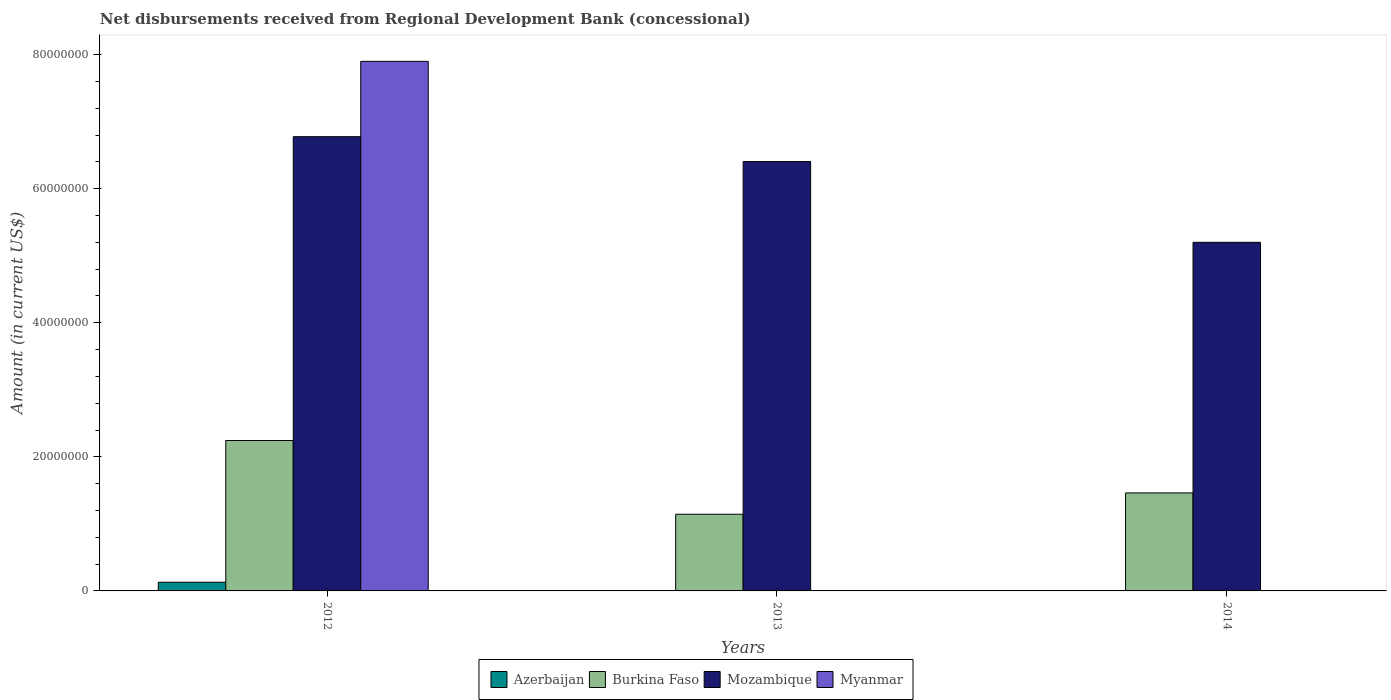How many groups of bars are there?
Provide a short and direct response. 3. Are the number of bars per tick equal to the number of legend labels?
Offer a terse response. No. Are the number of bars on each tick of the X-axis equal?
Ensure brevity in your answer.  No. What is the label of the 2nd group of bars from the left?
Give a very brief answer. 2013. In how many cases, is the number of bars for a given year not equal to the number of legend labels?
Your answer should be very brief. 2. What is the amount of disbursements received from Regional Development Bank in Mozambique in 2013?
Your answer should be very brief. 6.40e+07. Across all years, what is the maximum amount of disbursements received from Regional Development Bank in Myanmar?
Provide a short and direct response. 7.90e+07. Across all years, what is the minimum amount of disbursements received from Regional Development Bank in Burkina Faso?
Provide a short and direct response. 1.14e+07. In which year was the amount of disbursements received from Regional Development Bank in Burkina Faso maximum?
Your answer should be very brief. 2012. What is the total amount of disbursements received from Regional Development Bank in Myanmar in the graph?
Offer a terse response. 7.90e+07. What is the difference between the amount of disbursements received from Regional Development Bank in Burkina Faso in 2012 and that in 2013?
Offer a very short reply. 1.10e+07. What is the difference between the amount of disbursements received from Regional Development Bank in Mozambique in 2014 and the amount of disbursements received from Regional Development Bank in Myanmar in 2012?
Offer a terse response. -2.70e+07. What is the average amount of disbursements received from Regional Development Bank in Mozambique per year?
Provide a succinct answer. 6.13e+07. In the year 2012, what is the difference between the amount of disbursements received from Regional Development Bank in Azerbaijan and amount of disbursements received from Regional Development Bank in Mozambique?
Your answer should be very brief. -6.65e+07. What is the ratio of the amount of disbursements received from Regional Development Bank in Burkina Faso in 2012 to that in 2014?
Offer a terse response. 1.53. What is the difference between the highest and the second highest amount of disbursements received from Regional Development Bank in Mozambique?
Give a very brief answer. 3.71e+06. What is the difference between the highest and the lowest amount of disbursements received from Regional Development Bank in Burkina Faso?
Your answer should be compact. 1.10e+07. Is the sum of the amount of disbursements received from Regional Development Bank in Burkina Faso in 2013 and 2014 greater than the maximum amount of disbursements received from Regional Development Bank in Myanmar across all years?
Offer a very short reply. No. Is it the case that in every year, the sum of the amount of disbursements received from Regional Development Bank in Myanmar and amount of disbursements received from Regional Development Bank in Mozambique is greater than the amount of disbursements received from Regional Development Bank in Azerbaijan?
Offer a very short reply. Yes. How many years are there in the graph?
Make the answer very short. 3. What is the difference between two consecutive major ticks on the Y-axis?
Your answer should be very brief. 2.00e+07. Does the graph contain any zero values?
Offer a terse response. Yes. Where does the legend appear in the graph?
Make the answer very short. Bottom center. What is the title of the graph?
Provide a short and direct response. Net disbursements received from Regional Development Bank (concessional). What is the label or title of the Y-axis?
Make the answer very short. Amount (in current US$). What is the Amount (in current US$) of Azerbaijan in 2012?
Your response must be concise. 1.30e+06. What is the Amount (in current US$) in Burkina Faso in 2012?
Give a very brief answer. 2.24e+07. What is the Amount (in current US$) of Mozambique in 2012?
Your answer should be compact. 6.78e+07. What is the Amount (in current US$) in Myanmar in 2012?
Make the answer very short. 7.90e+07. What is the Amount (in current US$) in Azerbaijan in 2013?
Your answer should be compact. 0. What is the Amount (in current US$) of Burkina Faso in 2013?
Provide a short and direct response. 1.14e+07. What is the Amount (in current US$) in Mozambique in 2013?
Your response must be concise. 6.40e+07. What is the Amount (in current US$) of Myanmar in 2013?
Your answer should be compact. 0. What is the Amount (in current US$) in Burkina Faso in 2014?
Your answer should be very brief. 1.46e+07. What is the Amount (in current US$) in Mozambique in 2014?
Offer a very short reply. 5.20e+07. What is the Amount (in current US$) in Myanmar in 2014?
Your response must be concise. 0. Across all years, what is the maximum Amount (in current US$) in Azerbaijan?
Keep it short and to the point. 1.30e+06. Across all years, what is the maximum Amount (in current US$) in Burkina Faso?
Give a very brief answer. 2.24e+07. Across all years, what is the maximum Amount (in current US$) in Mozambique?
Your answer should be very brief. 6.78e+07. Across all years, what is the maximum Amount (in current US$) in Myanmar?
Ensure brevity in your answer.  7.90e+07. Across all years, what is the minimum Amount (in current US$) of Burkina Faso?
Keep it short and to the point. 1.14e+07. Across all years, what is the minimum Amount (in current US$) in Mozambique?
Provide a succinct answer. 5.20e+07. Across all years, what is the minimum Amount (in current US$) in Myanmar?
Your response must be concise. 0. What is the total Amount (in current US$) in Azerbaijan in the graph?
Your answer should be very brief. 1.30e+06. What is the total Amount (in current US$) in Burkina Faso in the graph?
Give a very brief answer. 4.85e+07. What is the total Amount (in current US$) in Mozambique in the graph?
Make the answer very short. 1.84e+08. What is the total Amount (in current US$) in Myanmar in the graph?
Ensure brevity in your answer.  7.90e+07. What is the difference between the Amount (in current US$) of Burkina Faso in 2012 and that in 2013?
Offer a very short reply. 1.10e+07. What is the difference between the Amount (in current US$) of Mozambique in 2012 and that in 2013?
Offer a terse response. 3.71e+06. What is the difference between the Amount (in current US$) in Burkina Faso in 2012 and that in 2014?
Your answer should be compact. 7.82e+06. What is the difference between the Amount (in current US$) in Mozambique in 2012 and that in 2014?
Provide a short and direct response. 1.58e+07. What is the difference between the Amount (in current US$) in Burkina Faso in 2013 and that in 2014?
Keep it short and to the point. -3.18e+06. What is the difference between the Amount (in current US$) of Mozambique in 2013 and that in 2014?
Ensure brevity in your answer.  1.20e+07. What is the difference between the Amount (in current US$) of Azerbaijan in 2012 and the Amount (in current US$) of Burkina Faso in 2013?
Provide a succinct answer. -1.01e+07. What is the difference between the Amount (in current US$) in Azerbaijan in 2012 and the Amount (in current US$) in Mozambique in 2013?
Ensure brevity in your answer.  -6.27e+07. What is the difference between the Amount (in current US$) of Burkina Faso in 2012 and the Amount (in current US$) of Mozambique in 2013?
Keep it short and to the point. -4.16e+07. What is the difference between the Amount (in current US$) of Azerbaijan in 2012 and the Amount (in current US$) of Burkina Faso in 2014?
Your answer should be very brief. -1.33e+07. What is the difference between the Amount (in current US$) in Azerbaijan in 2012 and the Amount (in current US$) in Mozambique in 2014?
Provide a succinct answer. -5.07e+07. What is the difference between the Amount (in current US$) in Burkina Faso in 2012 and the Amount (in current US$) in Mozambique in 2014?
Ensure brevity in your answer.  -2.96e+07. What is the difference between the Amount (in current US$) in Burkina Faso in 2013 and the Amount (in current US$) in Mozambique in 2014?
Provide a succinct answer. -4.06e+07. What is the average Amount (in current US$) of Azerbaijan per year?
Your answer should be very brief. 4.32e+05. What is the average Amount (in current US$) of Burkina Faso per year?
Ensure brevity in your answer.  1.62e+07. What is the average Amount (in current US$) in Mozambique per year?
Ensure brevity in your answer.  6.13e+07. What is the average Amount (in current US$) in Myanmar per year?
Give a very brief answer. 2.63e+07. In the year 2012, what is the difference between the Amount (in current US$) of Azerbaijan and Amount (in current US$) of Burkina Faso?
Offer a terse response. -2.11e+07. In the year 2012, what is the difference between the Amount (in current US$) in Azerbaijan and Amount (in current US$) in Mozambique?
Offer a very short reply. -6.65e+07. In the year 2012, what is the difference between the Amount (in current US$) of Azerbaijan and Amount (in current US$) of Myanmar?
Provide a succinct answer. -7.77e+07. In the year 2012, what is the difference between the Amount (in current US$) of Burkina Faso and Amount (in current US$) of Mozambique?
Provide a short and direct response. -4.53e+07. In the year 2012, what is the difference between the Amount (in current US$) of Burkina Faso and Amount (in current US$) of Myanmar?
Make the answer very short. -5.66e+07. In the year 2012, what is the difference between the Amount (in current US$) in Mozambique and Amount (in current US$) in Myanmar?
Offer a very short reply. -1.12e+07. In the year 2013, what is the difference between the Amount (in current US$) of Burkina Faso and Amount (in current US$) of Mozambique?
Your answer should be compact. -5.26e+07. In the year 2014, what is the difference between the Amount (in current US$) of Burkina Faso and Amount (in current US$) of Mozambique?
Ensure brevity in your answer.  -3.74e+07. What is the ratio of the Amount (in current US$) in Burkina Faso in 2012 to that in 2013?
Give a very brief answer. 1.96. What is the ratio of the Amount (in current US$) of Mozambique in 2012 to that in 2013?
Make the answer very short. 1.06. What is the ratio of the Amount (in current US$) in Burkina Faso in 2012 to that in 2014?
Offer a terse response. 1.53. What is the ratio of the Amount (in current US$) of Mozambique in 2012 to that in 2014?
Your answer should be very brief. 1.3. What is the ratio of the Amount (in current US$) in Burkina Faso in 2013 to that in 2014?
Make the answer very short. 0.78. What is the ratio of the Amount (in current US$) in Mozambique in 2013 to that in 2014?
Your response must be concise. 1.23. What is the difference between the highest and the second highest Amount (in current US$) of Burkina Faso?
Offer a terse response. 7.82e+06. What is the difference between the highest and the second highest Amount (in current US$) in Mozambique?
Ensure brevity in your answer.  3.71e+06. What is the difference between the highest and the lowest Amount (in current US$) of Azerbaijan?
Keep it short and to the point. 1.30e+06. What is the difference between the highest and the lowest Amount (in current US$) of Burkina Faso?
Offer a terse response. 1.10e+07. What is the difference between the highest and the lowest Amount (in current US$) of Mozambique?
Your answer should be compact. 1.58e+07. What is the difference between the highest and the lowest Amount (in current US$) in Myanmar?
Offer a very short reply. 7.90e+07. 